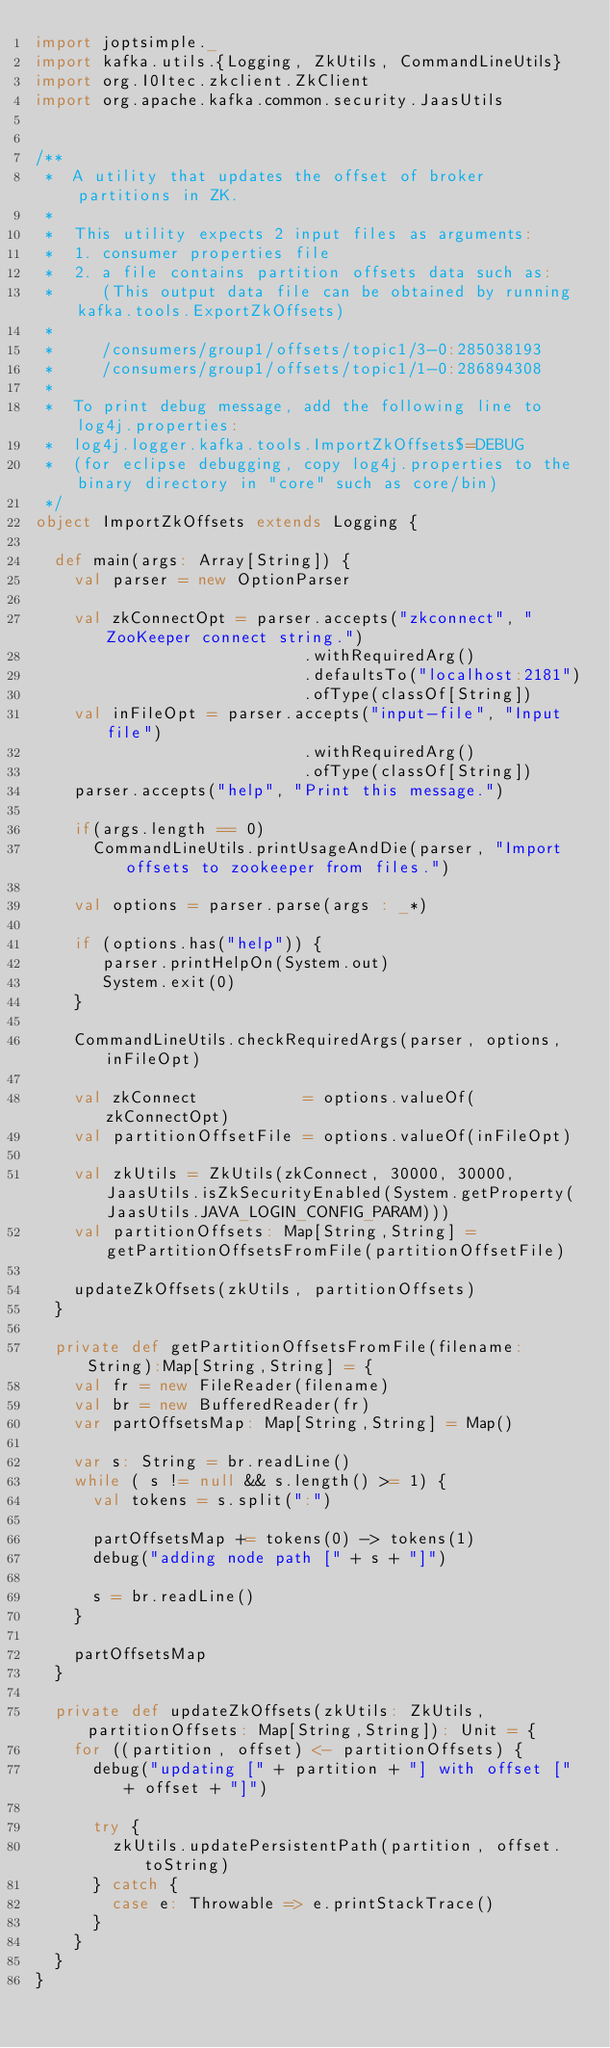<code> <loc_0><loc_0><loc_500><loc_500><_Scala_>import joptsimple._
import kafka.utils.{Logging, ZkUtils, CommandLineUtils}
import org.I0Itec.zkclient.ZkClient
import org.apache.kafka.common.security.JaasUtils


/**
 *  A utility that updates the offset of broker partitions in ZK.
 *  
 *  This utility expects 2 input files as arguments:
 *  1. consumer properties file
 *  2. a file contains partition offsets data such as:
 *     (This output data file can be obtained by running kafka.tools.ExportZkOffsets)
 *  
 *     /consumers/group1/offsets/topic1/3-0:285038193
 *     /consumers/group1/offsets/topic1/1-0:286894308
 *     
 *  To print debug message, add the following line to log4j.properties:
 *  log4j.logger.kafka.tools.ImportZkOffsets$=DEBUG
 *  (for eclipse debugging, copy log4j.properties to the binary directory in "core" such as core/bin)
 */
object ImportZkOffsets extends Logging {

  def main(args: Array[String]) {
    val parser = new OptionParser
    
    val zkConnectOpt = parser.accepts("zkconnect", "ZooKeeper connect string.")
                            .withRequiredArg()
                            .defaultsTo("localhost:2181")
                            .ofType(classOf[String])
    val inFileOpt = parser.accepts("input-file", "Input file")
                            .withRequiredArg()
                            .ofType(classOf[String])
    parser.accepts("help", "Print this message.")
    
    if(args.length == 0)
      CommandLineUtils.printUsageAndDie(parser, "Import offsets to zookeeper from files.")
            
    val options = parser.parse(args : _*)
    
    if (options.has("help")) {
       parser.printHelpOn(System.out)
       System.exit(0)
    }
    
    CommandLineUtils.checkRequiredArgs(parser, options, inFileOpt)
    
    val zkConnect           = options.valueOf(zkConnectOpt)
    val partitionOffsetFile = options.valueOf(inFileOpt)

    val zkUtils = ZkUtils(zkConnect, 30000, 30000, JaasUtils.isZkSecurityEnabled(System.getProperty(JaasUtils.JAVA_LOGIN_CONFIG_PARAM)))
    val partitionOffsets: Map[String,String] = getPartitionOffsetsFromFile(partitionOffsetFile)

    updateZkOffsets(zkUtils, partitionOffsets)
  }

  private def getPartitionOffsetsFromFile(filename: String):Map[String,String] = {
    val fr = new FileReader(filename)
    val br = new BufferedReader(fr)
    var partOffsetsMap: Map[String,String] = Map()
    
    var s: String = br.readLine()
    while ( s != null && s.length() >= 1) {
      val tokens = s.split(":")
      
      partOffsetsMap += tokens(0) -> tokens(1)
      debug("adding node path [" + s + "]")
      
      s = br.readLine()
    }
    
    partOffsetsMap
  }
  
  private def updateZkOffsets(zkUtils: ZkUtils, partitionOffsets: Map[String,String]): Unit = {
    for ((partition, offset) <- partitionOffsets) {
      debug("updating [" + partition + "] with offset [" + offset + "]")
      
      try {
        zkUtils.updatePersistentPath(partition, offset.toString)
      } catch {
        case e: Throwable => e.printStackTrace()
      }
    }
  }
}
</code> 